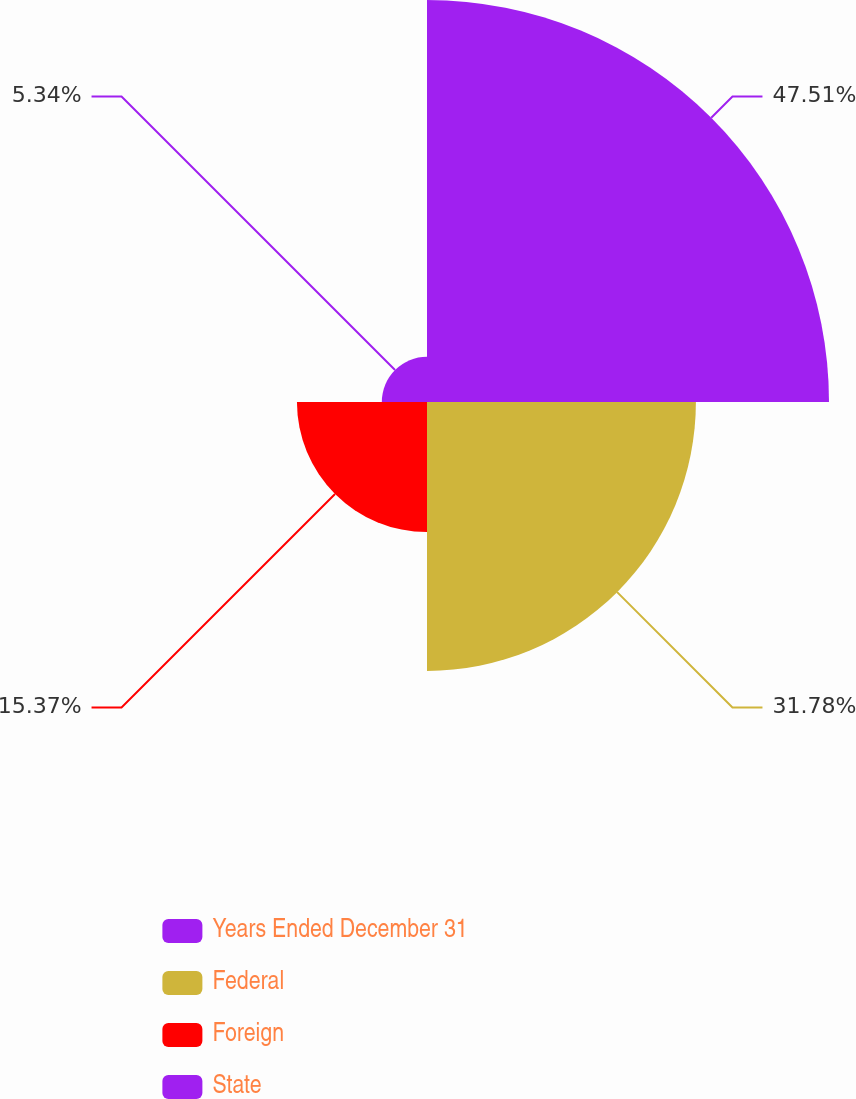Convert chart. <chart><loc_0><loc_0><loc_500><loc_500><pie_chart><fcel>Years Ended December 31<fcel>Federal<fcel>Foreign<fcel>State<nl><fcel>47.51%<fcel>31.78%<fcel>15.37%<fcel>5.34%<nl></chart> 